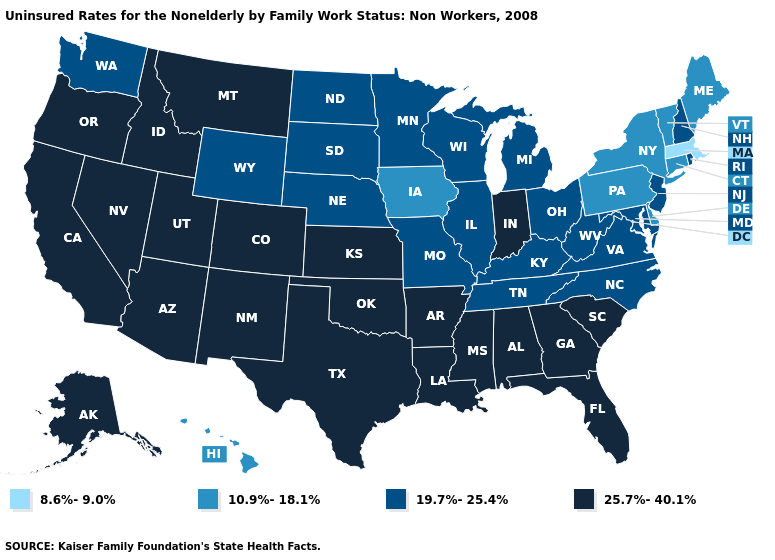What is the lowest value in the South?
Answer briefly. 10.9%-18.1%. What is the value of Wyoming?
Quick response, please. 19.7%-25.4%. Name the states that have a value in the range 10.9%-18.1%?
Write a very short answer. Connecticut, Delaware, Hawaii, Iowa, Maine, New York, Pennsylvania, Vermont. Among the states that border Florida , which have the highest value?
Short answer required. Alabama, Georgia. What is the value of Texas?
Be succinct. 25.7%-40.1%. What is the lowest value in the Northeast?
Answer briefly. 8.6%-9.0%. What is the value of New Mexico?
Concise answer only. 25.7%-40.1%. How many symbols are there in the legend?
Keep it brief. 4. Name the states that have a value in the range 10.9%-18.1%?
Be succinct. Connecticut, Delaware, Hawaii, Iowa, Maine, New York, Pennsylvania, Vermont. Name the states that have a value in the range 25.7%-40.1%?
Write a very short answer. Alabama, Alaska, Arizona, Arkansas, California, Colorado, Florida, Georgia, Idaho, Indiana, Kansas, Louisiana, Mississippi, Montana, Nevada, New Mexico, Oklahoma, Oregon, South Carolina, Texas, Utah. Name the states that have a value in the range 8.6%-9.0%?
Quick response, please. Massachusetts. Name the states that have a value in the range 19.7%-25.4%?
Keep it brief. Illinois, Kentucky, Maryland, Michigan, Minnesota, Missouri, Nebraska, New Hampshire, New Jersey, North Carolina, North Dakota, Ohio, Rhode Island, South Dakota, Tennessee, Virginia, Washington, West Virginia, Wisconsin, Wyoming. What is the value of Michigan?
Write a very short answer. 19.7%-25.4%. What is the value of Alaska?
Quick response, please. 25.7%-40.1%. What is the value of Ohio?
Quick response, please. 19.7%-25.4%. 